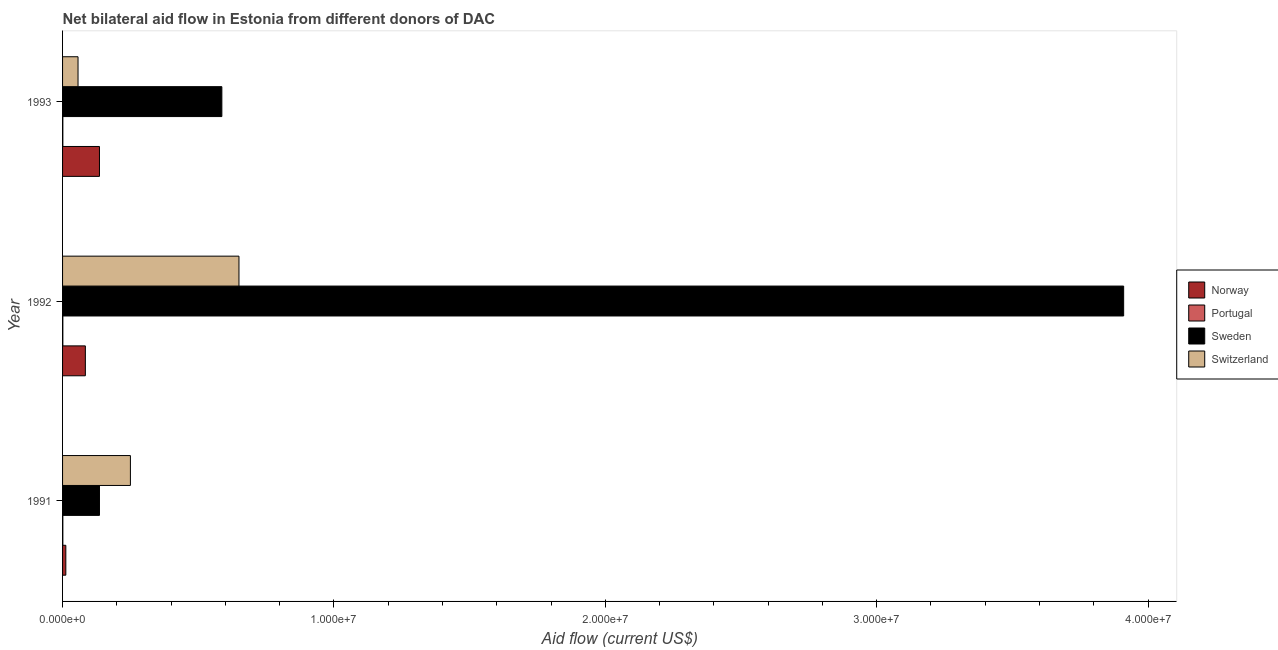How many different coloured bars are there?
Your answer should be compact. 4. Are the number of bars per tick equal to the number of legend labels?
Your answer should be compact. Yes. How many bars are there on the 2nd tick from the top?
Provide a short and direct response. 4. What is the label of the 1st group of bars from the top?
Your answer should be very brief. 1993. In how many cases, is the number of bars for a given year not equal to the number of legend labels?
Keep it short and to the point. 0. What is the amount of aid given by sweden in 1991?
Provide a succinct answer. 1.36e+06. Across all years, what is the maximum amount of aid given by sweden?
Ensure brevity in your answer.  3.91e+07. Across all years, what is the minimum amount of aid given by switzerland?
Keep it short and to the point. 5.70e+05. In which year was the amount of aid given by sweden minimum?
Your answer should be very brief. 1991. What is the total amount of aid given by portugal in the graph?
Ensure brevity in your answer.  3.00e+04. What is the difference between the amount of aid given by norway in 1991 and that in 1993?
Your answer should be compact. -1.24e+06. What is the difference between the amount of aid given by switzerland in 1991 and the amount of aid given by portugal in 1992?
Your answer should be compact. 2.49e+06. What is the average amount of aid given by norway per year?
Make the answer very short. 7.73e+05. In the year 1992, what is the difference between the amount of aid given by switzerland and amount of aid given by sweden?
Offer a very short reply. -3.26e+07. What is the ratio of the amount of aid given by sweden in 1991 to that in 1993?
Give a very brief answer. 0.23. What is the difference between the highest and the second highest amount of aid given by norway?
Offer a terse response. 5.20e+05. What is the difference between the highest and the lowest amount of aid given by switzerland?
Offer a very short reply. 5.93e+06. In how many years, is the amount of aid given by norway greater than the average amount of aid given by norway taken over all years?
Offer a very short reply. 2. Is it the case that in every year, the sum of the amount of aid given by portugal and amount of aid given by switzerland is greater than the sum of amount of aid given by norway and amount of aid given by sweden?
Give a very brief answer. No. What does the 1st bar from the top in 1992 represents?
Your response must be concise. Switzerland. How many bars are there?
Make the answer very short. 12. How many years are there in the graph?
Offer a very short reply. 3. Does the graph contain grids?
Offer a very short reply. No. How many legend labels are there?
Provide a short and direct response. 4. What is the title of the graph?
Ensure brevity in your answer.  Net bilateral aid flow in Estonia from different donors of DAC. Does "Second 20% of population" appear as one of the legend labels in the graph?
Your response must be concise. No. What is the label or title of the Y-axis?
Provide a succinct answer. Year. What is the Aid flow (current US$) in Norway in 1991?
Your answer should be very brief. 1.20e+05. What is the Aid flow (current US$) of Portugal in 1991?
Provide a succinct answer. 10000. What is the Aid flow (current US$) in Sweden in 1991?
Provide a succinct answer. 1.36e+06. What is the Aid flow (current US$) in Switzerland in 1991?
Make the answer very short. 2.50e+06. What is the Aid flow (current US$) of Norway in 1992?
Offer a very short reply. 8.40e+05. What is the Aid flow (current US$) of Portugal in 1992?
Your answer should be compact. 10000. What is the Aid flow (current US$) in Sweden in 1992?
Provide a short and direct response. 3.91e+07. What is the Aid flow (current US$) of Switzerland in 1992?
Ensure brevity in your answer.  6.50e+06. What is the Aid flow (current US$) in Norway in 1993?
Keep it short and to the point. 1.36e+06. What is the Aid flow (current US$) in Sweden in 1993?
Your response must be concise. 5.87e+06. What is the Aid flow (current US$) of Switzerland in 1993?
Ensure brevity in your answer.  5.70e+05. Across all years, what is the maximum Aid flow (current US$) of Norway?
Your response must be concise. 1.36e+06. Across all years, what is the maximum Aid flow (current US$) in Sweden?
Ensure brevity in your answer.  3.91e+07. Across all years, what is the maximum Aid flow (current US$) in Switzerland?
Make the answer very short. 6.50e+06. Across all years, what is the minimum Aid flow (current US$) in Sweden?
Provide a short and direct response. 1.36e+06. Across all years, what is the minimum Aid flow (current US$) of Switzerland?
Offer a terse response. 5.70e+05. What is the total Aid flow (current US$) in Norway in the graph?
Ensure brevity in your answer.  2.32e+06. What is the total Aid flow (current US$) in Portugal in the graph?
Offer a very short reply. 3.00e+04. What is the total Aid flow (current US$) of Sweden in the graph?
Keep it short and to the point. 4.63e+07. What is the total Aid flow (current US$) of Switzerland in the graph?
Offer a terse response. 9.57e+06. What is the difference between the Aid flow (current US$) in Norway in 1991 and that in 1992?
Your response must be concise. -7.20e+05. What is the difference between the Aid flow (current US$) of Portugal in 1991 and that in 1992?
Provide a short and direct response. 0. What is the difference between the Aid flow (current US$) of Sweden in 1991 and that in 1992?
Your answer should be compact. -3.77e+07. What is the difference between the Aid flow (current US$) in Norway in 1991 and that in 1993?
Your answer should be very brief. -1.24e+06. What is the difference between the Aid flow (current US$) in Portugal in 1991 and that in 1993?
Offer a very short reply. 0. What is the difference between the Aid flow (current US$) in Sweden in 1991 and that in 1993?
Make the answer very short. -4.51e+06. What is the difference between the Aid flow (current US$) of Switzerland in 1991 and that in 1993?
Make the answer very short. 1.93e+06. What is the difference between the Aid flow (current US$) of Norway in 1992 and that in 1993?
Ensure brevity in your answer.  -5.20e+05. What is the difference between the Aid flow (current US$) of Sweden in 1992 and that in 1993?
Give a very brief answer. 3.32e+07. What is the difference between the Aid flow (current US$) of Switzerland in 1992 and that in 1993?
Your answer should be compact. 5.93e+06. What is the difference between the Aid flow (current US$) in Norway in 1991 and the Aid flow (current US$) in Portugal in 1992?
Make the answer very short. 1.10e+05. What is the difference between the Aid flow (current US$) of Norway in 1991 and the Aid flow (current US$) of Sweden in 1992?
Your answer should be very brief. -3.90e+07. What is the difference between the Aid flow (current US$) in Norway in 1991 and the Aid flow (current US$) in Switzerland in 1992?
Your answer should be compact. -6.38e+06. What is the difference between the Aid flow (current US$) of Portugal in 1991 and the Aid flow (current US$) of Sweden in 1992?
Keep it short and to the point. -3.91e+07. What is the difference between the Aid flow (current US$) of Portugal in 1991 and the Aid flow (current US$) of Switzerland in 1992?
Your answer should be very brief. -6.49e+06. What is the difference between the Aid flow (current US$) in Sweden in 1991 and the Aid flow (current US$) in Switzerland in 1992?
Your answer should be very brief. -5.14e+06. What is the difference between the Aid flow (current US$) of Norway in 1991 and the Aid flow (current US$) of Portugal in 1993?
Keep it short and to the point. 1.10e+05. What is the difference between the Aid flow (current US$) of Norway in 1991 and the Aid flow (current US$) of Sweden in 1993?
Your answer should be compact. -5.75e+06. What is the difference between the Aid flow (current US$) of Norway in 1991 and the Aid flow (current US$) of Switzerland in 1993?
Your answer should be compact. -4.50e+05. What is the difference between the Aid flow (current US$) in Portugal in 1991 and the Aid flow (current US$) in Sweden in 1993?
Provide a short and direct response. -5.86e+06. What is the difference between the Aid flow (current US$) in Portugal in 1991 and the Aid flow (current US$) in Switzerland in 1993?
Provide a short and direct response. -5.60e+05. What is the difference between the Aid flow (current US$) in Sweden in 1991 and the Aid flow (current US$) in Switzerland in 1993?
Offer a very short reply. 7.90e+05. What is the difference between the Aid flow (current US$) of Norway in 1992 and the Aid flow (current US$) of Portugal in 1993?
Offer a very short reply. 8.30e+05. What is the difference between the Aid flow (current US$) of Norway in 1992 and the Aid flow (current US$) of Sweden in 1993?
Your answer should be compact. -5.03e+06. What is the difference between the Aid flow (current US$) in Portugal in 1992 and the Aid flow (current US$) in Sweden in 1993?
Your response must be concise. -5.86e+06. What is the difference between the Aid flow (current US$) of Portugal in 1992 and the Aid flow (current US$) of Switzerland in 1993?
Your answer should be very brief. -5.60e+05. What is the difference between the Aid flow (current US$) of Sweden in 1992 and the Aid flow (current US$) of Switzerland in 1993?
Give a very brief answer. 3.85e+07. What is the average Aid flow (current US$) in Norway per year?
Give a very brief answer. 7.73e+05. What is the average Aid flow (current US$) of Sweden per year?
Keep it short and to the point. 1.54e+07. What is the average Aid flow (current US$) of Switzerland per year?
Your answer should be very brief. 3.19e+06. In the year 1991, what is the difference between the Aid flow (current US$) in Norway and Aid flow (current US$) in Sweden?
Your answer should be compact. -1.24e+06. In the year 1991, what is the difference between the Aid flow (current US$) of Norway and Aid flow (current US$) of Switzerland?
Your answer should be very brief. -2.38e+06. In the year 1991, what is the difference between the Aid flow (current US$) in Portugal and Aid flow (current US$) in Sweden?
Offer a very short reply. -1.35e+06. In the year 1991, what is the difference between the Aid flow (current US$) in Portugal and Aid flow (current US$) in Switzerland?
Provide a short and direct response. -2.49e+06. In the year 1991, what is the difference between the Aid flow (current US$) of Sweden and Aid flow (current US$) of Switzerland?
Provide a succinct answer. -1.14e+06. In the year 1992, what is the difference between the Aid flow (current US$) in Norway and Aid flow (current US$) in Portugal?
Ensure brevity in your answer.  8.30e+05. In the year 1992, what is the difference between the Aid flow (current US$) of Norway and Aid flow (current US$) of Sweden?
Provide a succinct answer. -3.83e+07. In the year 1992, what is the difference between the Aid flow (current US$) in Norway and Aid flow (current US$) in Switzerland?
Your answer should be very brief. -5.66e+06. In the year 1992, what is the difference between the Aid flow (current US$) of Portugal and Aid flow (current US$) of Sweden?
Provide a short and direct response. -3.91e+07. In the year 1992, what is the difference between the Aid flow (current US$) in Portugal and Aid flow (current US$) in Switzerland?
Ensure brevity in your answer.  -6.49e+06. In the year 1992, what is the difference between the Aid flow (current US$) of Sweden and Aid flow (current US$) of Switzerland?
Provide a succinct answer. 3.26e+07. In the year 1993, what is the difference between the Aid flow (current US$) in Norway and Aid flow (current US$) in Portugal?
Your answer should be very brief. 1.35e+06. In the year 1993, what is the difference between the Aid flow (current US$) in Norway and Aid flow (current US$) in Sweden?
Give a very brief answer. -4.51e+06. In the year 1993, what is the difference between the Aid flow (current US$) in Norway and Aid flow (current US$) in Switzerland?
Provide a succinct answer. 7.90e+05. In the year 1993, what is the difference between the Aid flow (current US$) in Portugal and Aid flow (current US$) in Sweden?
Your answer should be compact. -5.86e+06. In the year 1993, what is the difference between the Aid flow (current US$) of Portugal and Aid flow (current US$) of Switzerland?
Your response must be concise. -5.60e+05. In the year 1993, what is the difference between the Aid flow (current US$) of Sweden and Aid flow (current US$) of Switzerland?
Your response must be concise. 5.30e+06. What is the ratio of the Aid flow (current US$) in Norway in 1991 to that in 1992?
Make the answer very short. 0.14. What is the ratio of the Aid flow (current US$) in Sweden in 1991 to that in 1992?
Make the answer very short. 0.03. What is the ratio of the Aid flow (current US$) in Switzerland in 1991 to that in 1992?
Make the answer very short. 0.38. What is the ratio of the Aid flow (current US$) of Norway in 1991 to that in 1993?
Keep it short and to the point. 0.09. What is the ratio of the Aid flow (current US$) of Portugal in 1991 to that in 1993?
Ensure brevity in your answer.  1. What is the ratio of the Aid flow (current US$) in Sweden in 1991 to that in 1993?
Offer a very short reply. 0.23. What is the ratio of the Aid flow (current US$) of Switzerland in 1991 to that in 1993?
Provide a succinct answer. 4.39. What is the ratio of the Aid flow (current US$) in Norway in 1992 to that in 1993?
Provide a succinct answer. 0.62. What is the ratio of the Aid flow (current US$) in Sweden in 1992 to that in 1993?
Make the answer very short. 6.66. What is the ratio of the Aid flow (current US$) in Switzerland in 1992 to that in 1993?
Ensure brevity in your answer.  11.4. What is the difference between the highest and the second highest Aid flow (current US$) of Norway?
Ensure brevity in your answer.  5.20e+05. What is the difference between the highest and the second highest Aid flow (current US$) of Portugal?
Your answer should be very brief. 0. What is the difference between the highest and the second highest Aid flow (current US$) of Sweden?
Make the answer very short. 3.32e+07. What is the difference between the highest and the lowest Aid flow (current US$) of Norway?
Provide a succinct answer. 1.24e+06. What is the difference between the highest and the lowest Aid flow (current US$) of Portugal?
Ensure brevity in your answer.  0. What is the difference between the highest and the lowest Aid flow (current US$) of Sweden?
Give a very brief answer. 3.77e+07. What is the difference between the highest and the lowest Aid flow (current US$) in Switzerland?
Your answer should be very brief. 5.93e+06. 